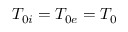<formula> <loc_0><loc_0><loc_500><loc_500>T _ { 0 i } = T _ { 0 e } = T _ { 0 }</formula> 